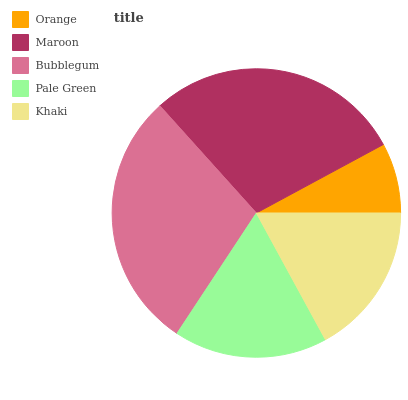Is Orange the minimum?
Answer yes or no. Yes. Is Bubblegum the maximum?
Answer yes or no. Yes. Is Maroon the minimum?
Answer yes or no. No. Is Maroon the maximum?
Answer yes or no. No. Is Maroon greater than Orange?
Answer yes or no. Yes. Is Orange less than Maroon?
Answer yes or no. Yes. Is Orange greater than Maroon?
Answer yes or no. No. Is Maroon less than Orange?
Answer yes or no. No. Is Pale Green the high median?
Answer yes or no. Yes. Is Pale Green the low median?
Answer yes or no. Yes. Is Orange the high median?
Answer yes or no. No. Is Orange the low median?
Answer yes or no. No. 